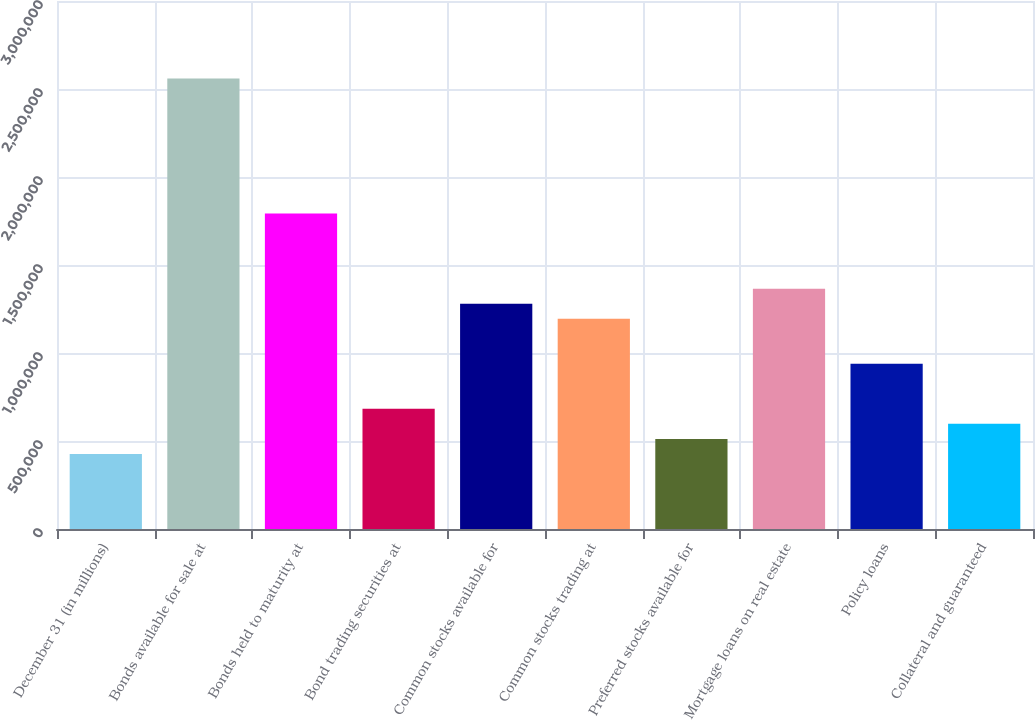Convert chart to OTSL. <chart><loc_0><loc_0><loc_500><loc_500><bar_chart><fcel>December 31 (in millions)<fcel>Bonds available for sale at<fcel>Bonds held to maturity at<fcel>Bond trading securities at<fcel>Common stocks available for<fcel>Common stocks trading at<fcel>Preferred stocks available for<fcel>Mortgage loans on real estate<fcel>Policy loans<fcel>Collateral and guaranteed<nl><fcel>426731<fcel>2.55993e+06<fcel>1.79198e+06<fcel>682714<fcel>1.28001e+06<fcel>1.19468e+06<fcel>512059<fcel>1.36534e+06<fcel>938698<fcel>597387<nl></chart> 